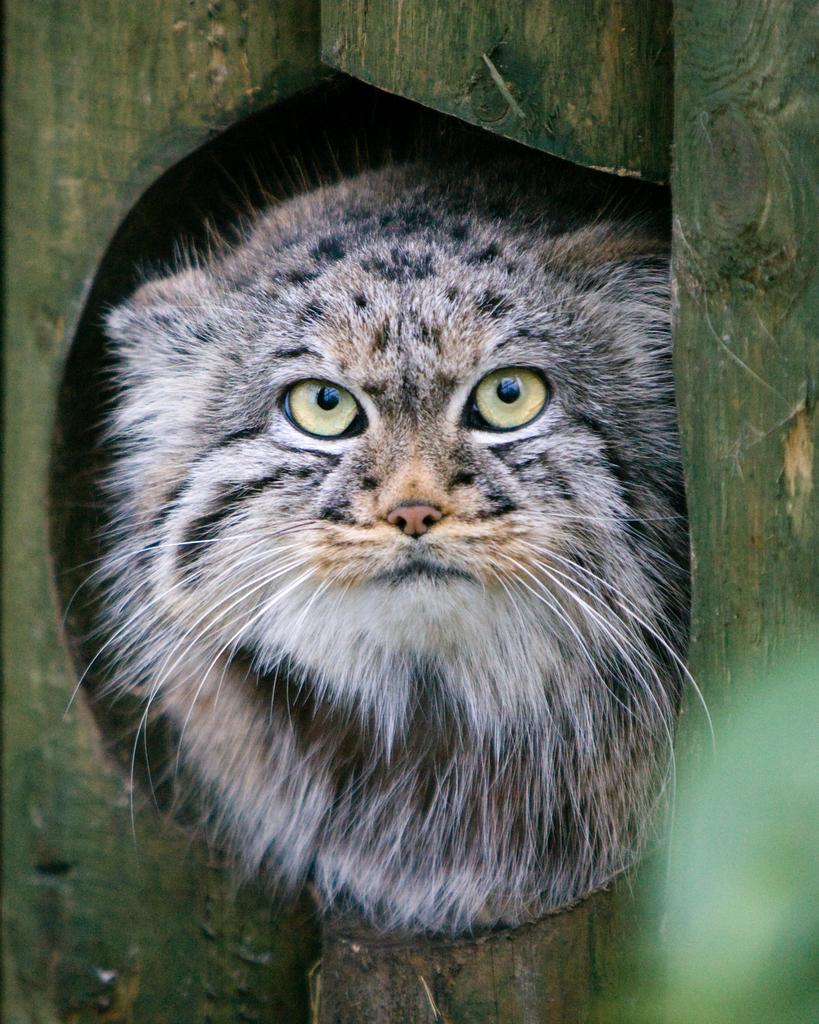How would you summarize this image in a sentence or two? In this image there is a cat, around the cat there are bamboo sticks. 